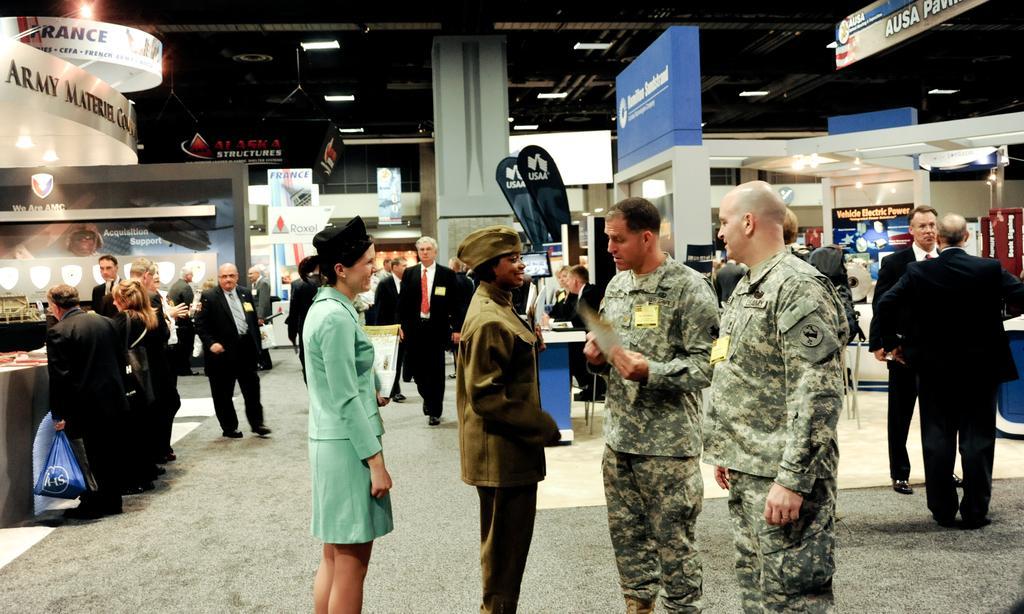Please provide a concise description of this image. In this image we can see the inner view of the building and there are some people among them few people wearing suits. There are some boards with text and we can see some lights attached to the ceiling. 